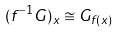Convert formula to latex. <formula><loc_0><loc_0><loc_500><loc_500>( f ^ { - 1 } G ) _ { x } \cong G _ { f ( x ) }</formula> 